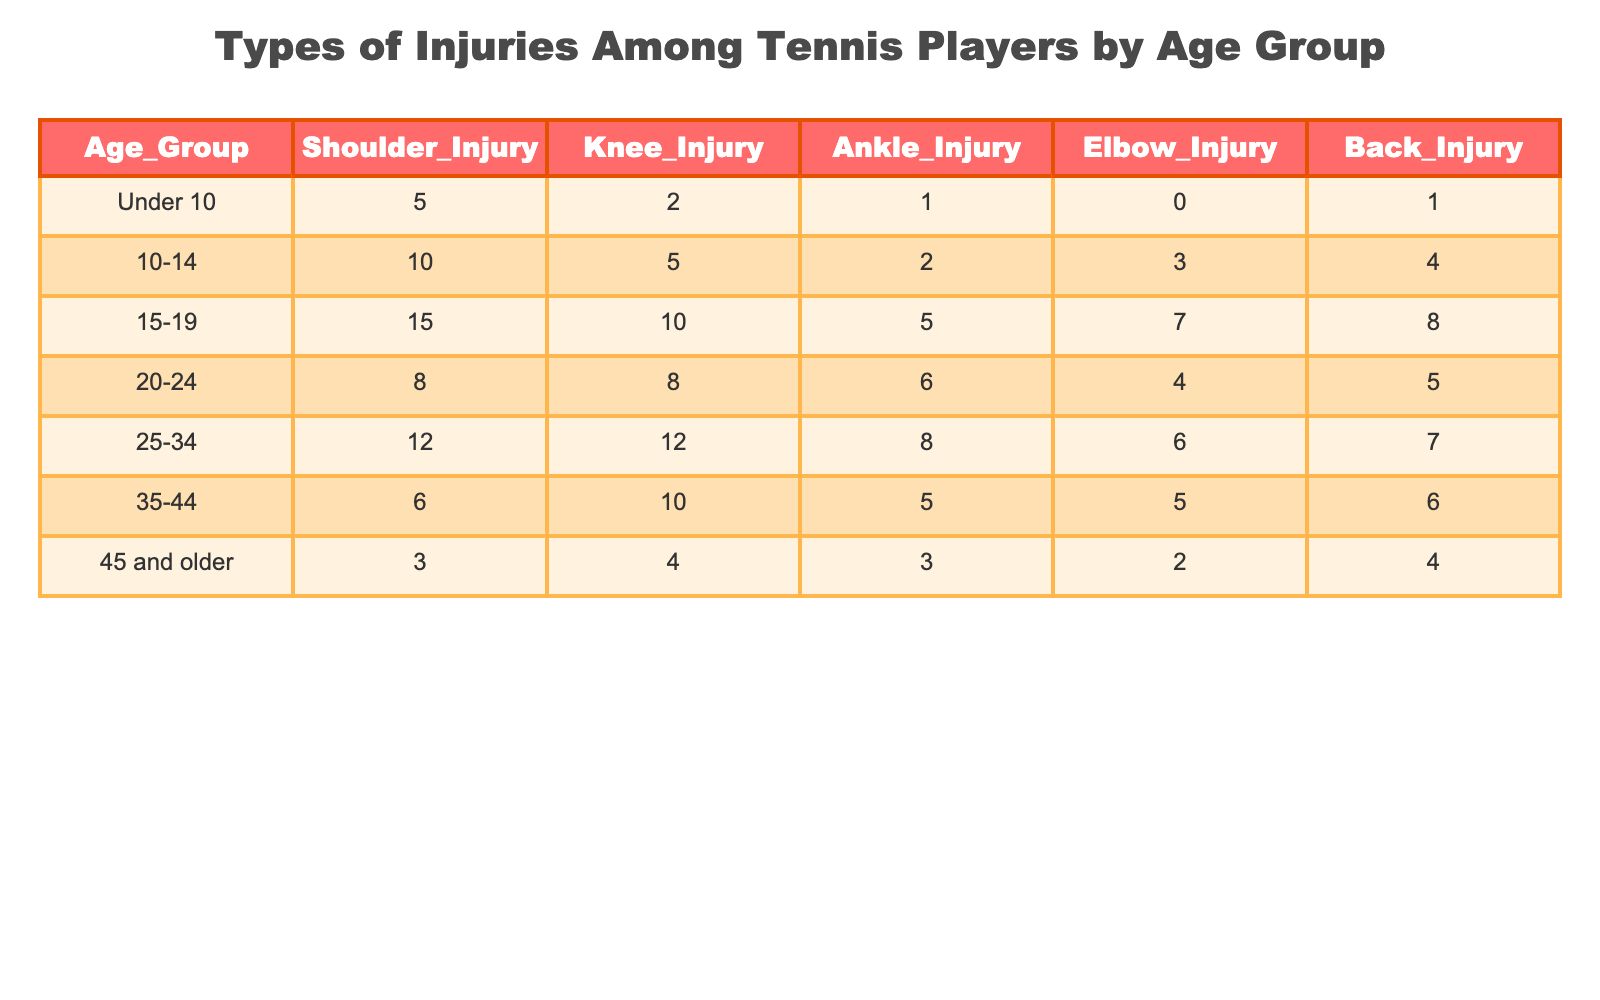What is the total number of shoulder injuries among players aged 10-14? Referring to the table, in the age group 10-14, the number of shoulder injuries is given as 10.
Answer: 10 Which age group has the highest number of knee injuries? Examining the table, the age group 15-19 has the highest number of knee injuries with a total of 10.
Answer: 15-19 What is the sum of ankle injuries across all age groups? To find the sum of ankle injuries, we add the values from each age group: 1 + 2 + 5 + 6 + 8 + 5 + 3 = 30.
Answer: 30 Is it true that players aged 45 and older have the least number of elbow injuries? The number of elbow injuries for players aged 45 and older is 2, which is less than any other age group, confirming the statement is true.
Answer: Yes What is the average number of back injuries for players aged 25-34 and 35-44 combined? For the age groups 25-34 and 35-44, the back injuries are 7 and 6 respectively. Their average is calculated as (7 + 6) / 2 = 6.5.
Answer: 6.5 Which age group has the least total injuries across all types? To find the total injuries for each age group, we sum up the injuries for each one. For 45 and older: 3 + 4 + 3 + 2 + 4 = 16, which is the lowest total compared to others.
Answer: 45 and older How many more shoulder injuries are there in the 15-19 age group compared to the 20-24 group? The number of shoulder injuries in the 15-19 age group is 15, and in the 20-24 group, it is 8. The difference is calculated as 15 - 8 = 7.
Answer: 7 What is the percentage of ankle injuries among players aged 25-34 compared to the total injuries in that age group? In the 25-34 age group, there are 8 ankle injuries and a total of 12 + 12 + 8 + 6 + 7 = 45 injuries. The percentage is calculated as (8 / 45) * 100 = 17.78%.
Answer: 17.78% 